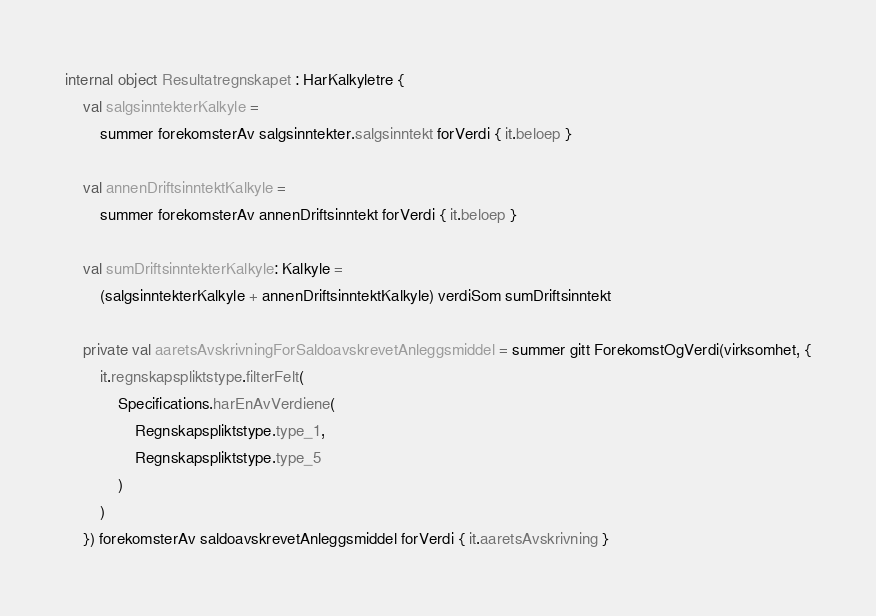Convert code to text. <code><loc_0><loc_0><loc_500><loc_500><_Kotlin_>internal object Resultatregnskapet : HarKalkyletre {
    val salgsinntekterKalkyle =
        summer forekomsterAv salgsinntekter.salgsinntekt forVerdi { it.beloep }

    val annenDriftsinntektKalkyle =
        summer forekomsterAv annenDriftsinntekt forVerdi { it.beloep }

    val sumDriftsinntekterKalkyle: Kalkyle =
        (salgsinntekterKalkyle + annenDriftsinntektKalkyle) verdiSom sumDriftsinntekt

    private val aaretsAvskrivningForSaldoavskrevetAnleggsmiddel = summer gitt ForekomstOgVerdi(virksomhet, {
        it.regnskapspliktstype.filterFelt(
            Specifications.harEnAvVerdiene(
                Regnskapspliktstype.type_1,
                Regnskapspliktstype.type_5
            )
        )
    }) forekomsterAv saldoavskrevetAnleggsmiddel forVerdi { it.aaretsAvskrivning }
</code> 